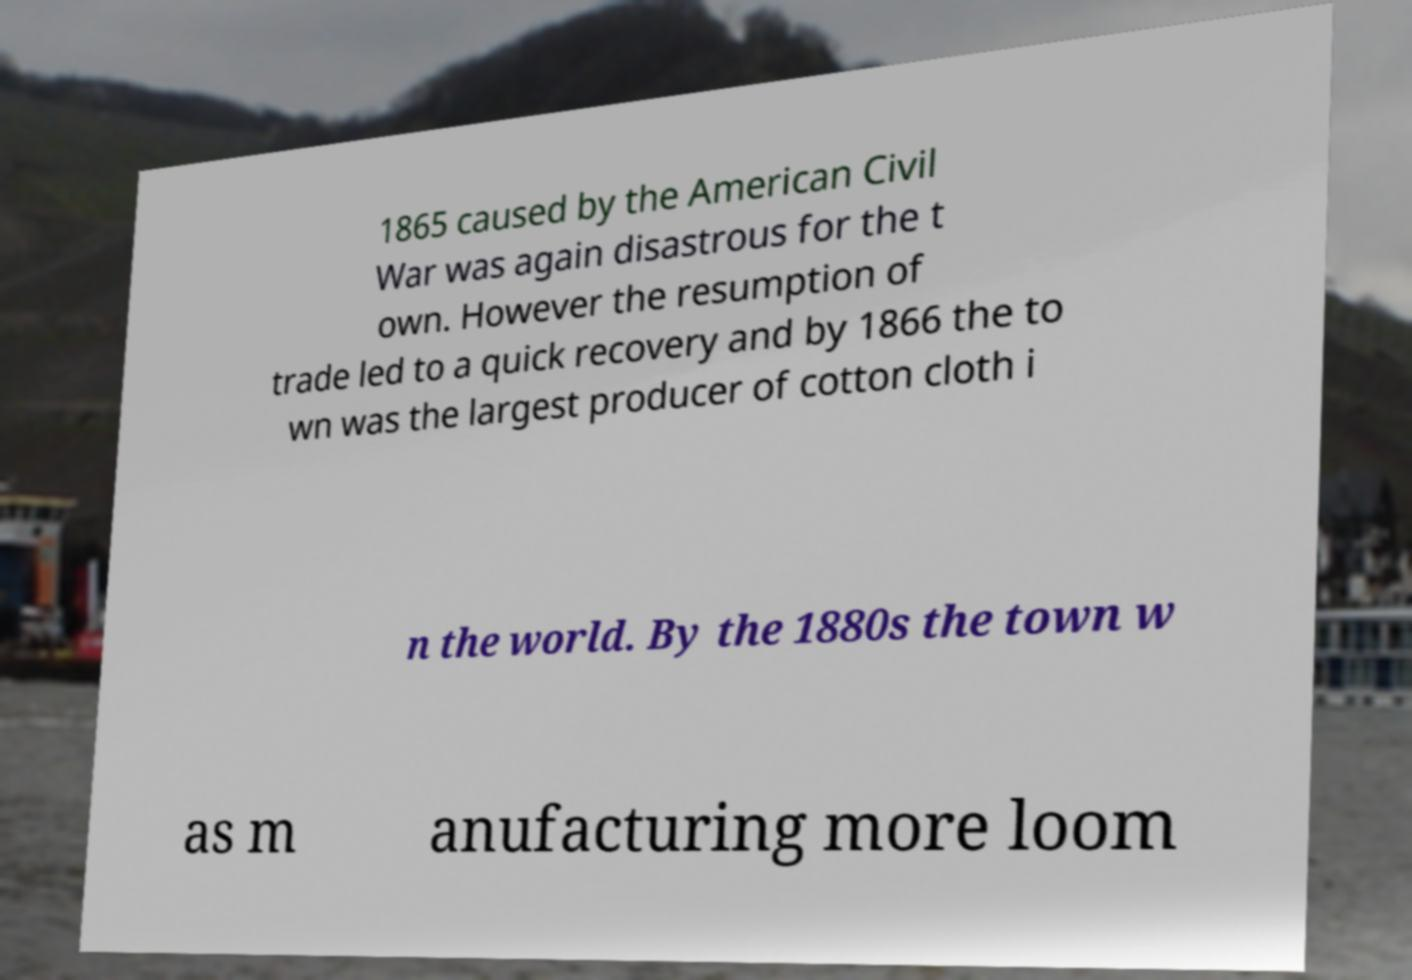For documentation purposes, I need the text within this image transcribed. Could you provide that? 1865 caused by the American Civil War was again disastrous for the t own. However the resumption of trade led to a quick recovery and by 1866 the to wn was the largest producer of cotton cloth i n the world. By the 1880s the town w as m anufacturing more loom 